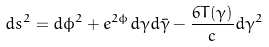Convert formula to latex. <formula><loc_0><loc_0><loc_500><loc_500>d s ^ { 2 } = d \phi ^ { 2 } + e ^ { 2 \phi } d \gamma d \bar { \gamma } - { \frac { 6 T ( \gamma ) } { c } } d \gamma ^ { 2 }</formula> 